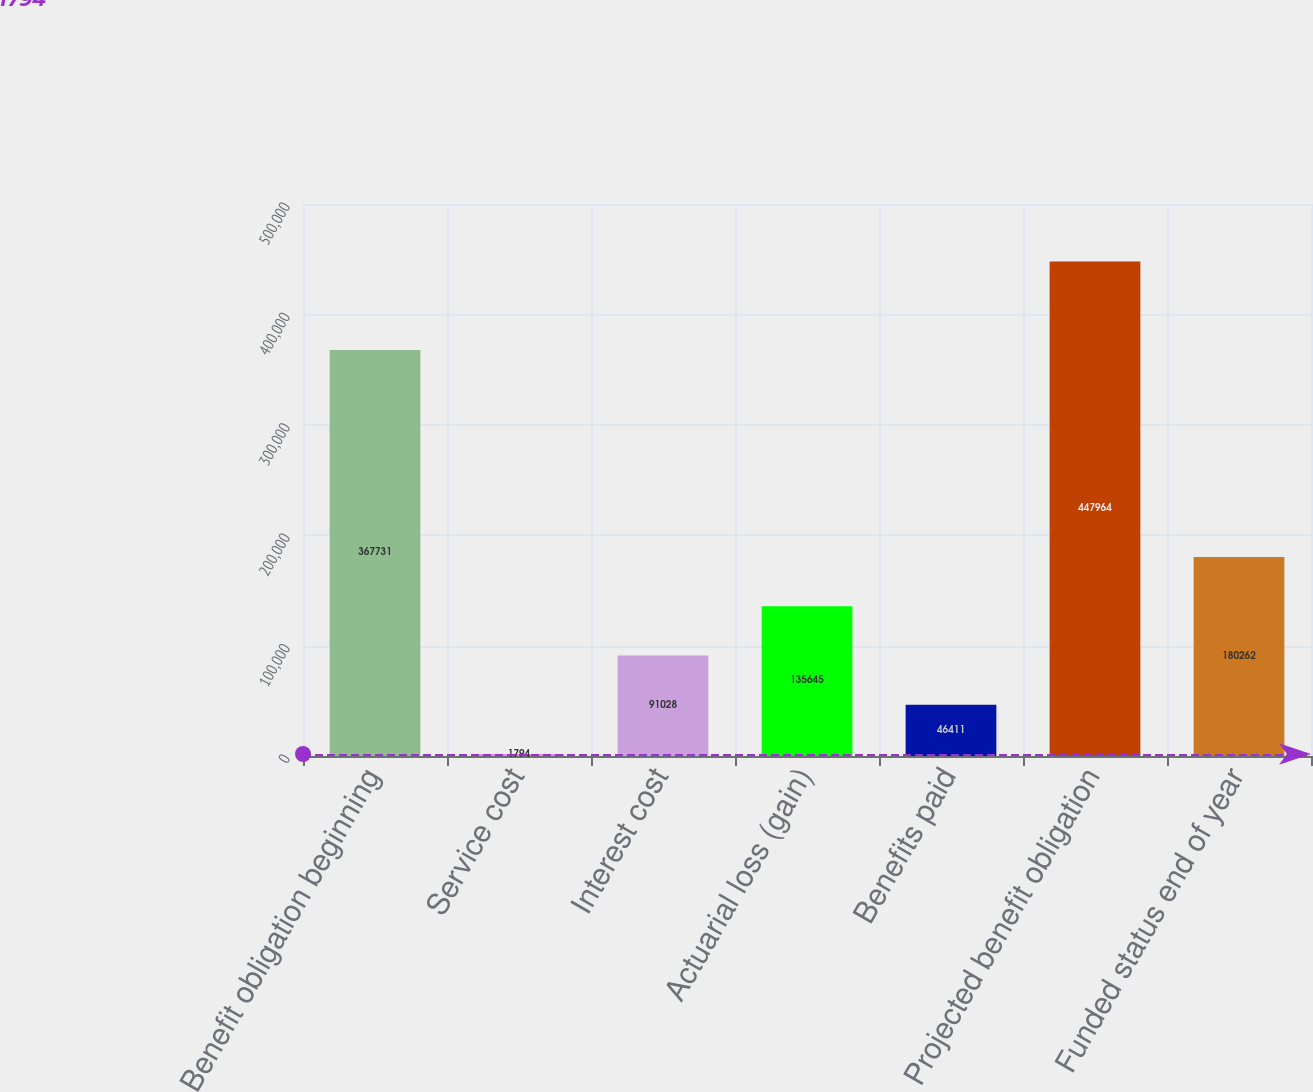Convert chart. <chart><loc_0><loc_0><loc_500><loc_500><bar_chart><fcel>Benefit obligation beginning<fcel>Service cost<fcel>Interest cost<fcel>Actuarial loss (gain)<fcel>Benefits paid<fcel>Projected benefit obligation<fcel>Funded status end of year<nl><fcel>367731<fcel>1794<fcel>91028<fcel>135645<fcel>46411<fcel>447964<fcel>180262<nl></chart> 